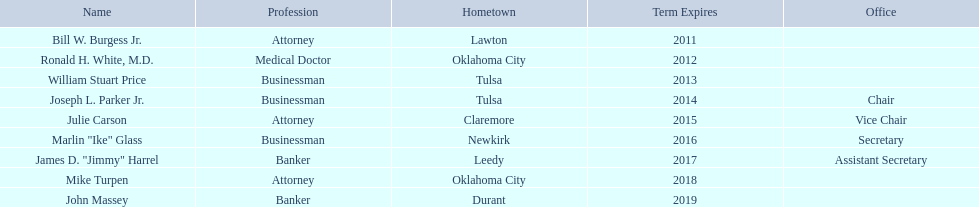Which regents are from tulsa? William Stuart Price, Joseph L. Parker Jr. Which of these is not joseph parker, jr.? William Stuart Price. 